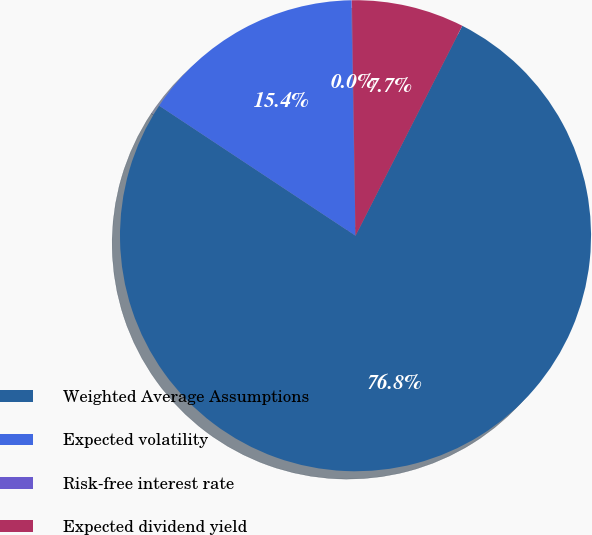Convert chart. <chart><loc_0><loc_0><loc_500><loc_500><pie_chart><fcel>Weighted Average Assumptions<fcel>Expected volatility<fcel>Risk-free interest rate<fcel>Expected dividend yield<nl><fcel>76.82%<fcel>15.4%<fcel>0.05%<fcel>7.73%<nl></chart> 